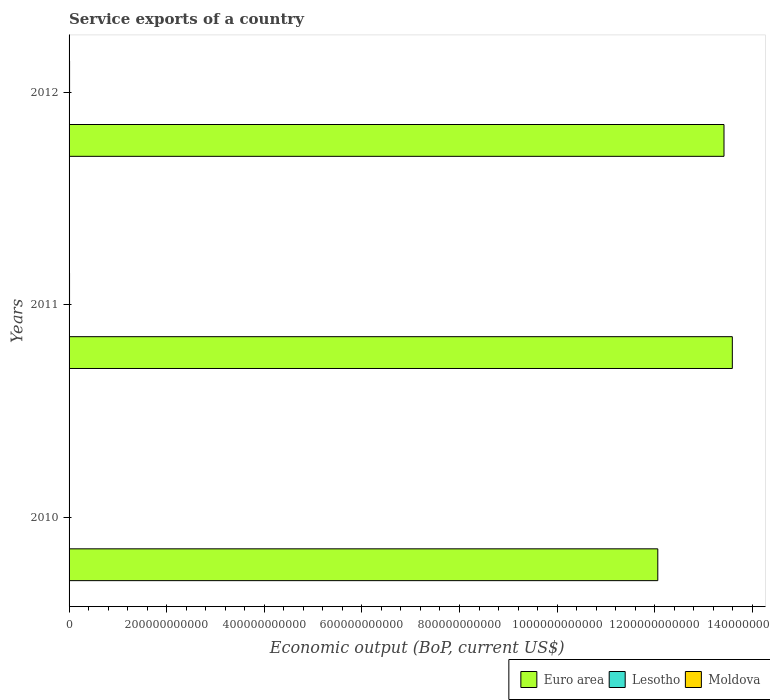How many different coloured bars are there?
Your answer should be compact. 3. How many groups of bars are there?
Keep it short and to the point. 3. Are the number of bars per tick equal to the number of legend labels?
Ensure brevity in your answer.  Yes. How many bars are there on the 3rd tick from the top?
Your answer should be very brief. 3. What is the label of the 2nd group of bars from the top?
Offer a terse response. 2011. In how many cases, is the number of bars for a given year not equal to the number of legend labels?
Keep it short and to the point. 0. What is the service exports in Moldova in 2011?
Make the answer very short. 9.60e+08. Across all years, what is the maximum service exports in Lesotho?
Your answer should be very brief. 7.29e+07. Across all years, what is the minimum service exports in Lesotho?
Your answer should be compact. 4.77e+07. In which year was the service exports in Euro area maximum?
Offer a terse response. 2011. In which year was the service exports in Moldova minimum?
Your answer should be very brief. 2010. What is the total service exports in Lesotho in the graph?
Your answer should be compact. 1.71e+08. What is the difference between the service exports in Lesotho in 2010 and that in 2011?
Ensure brevity in your answer.  -3.10e+06. What is the difference between the service exports in Lesotho in 2010 and the service exports in Euro area in 2012?
Give a very brief answer. -1.34e+12. What is the average service exports in Lesotho per year?
Offer a very short reply. 5.72e+07. In the year 2012, what is the difference between the service exports in Moldova and service exports in Euro area?
Provide a short and direct response. -1.34e+12. What is the ratio of the service exports in Lesotho in 2010 to that in 2012?
Provide a short and direct response. 0.65. Is the service exports in Euro area in 2010 less than that in 2011?
Provide a short and direct response. Yes. What is the difference between the highest and the second highest service exports in Euro area?
Your answer should be compact. 1.71e+1. What is the difference between the highest and the lowest service exports in Moldova?
Offer a very short reply. 2.51e+08. Is the sum of the service exports in Euro area in 2011 and 2012 greater than the maximum service exports in Lesotho across all years?
Provide a succinct answer. Yes. What does the 1st bar from the top in 2011 represents?
Keep it short and to the point. Moldova. What does the 1st bar from the bottom in 2012 represents?
Make the answer very short. Euro area. How many bars are there?
Make the answer very short. 9. How many years are there in the graph?
Provide a succinct answer. 3. What is the difference between two consecutive major ticks on the X-axis?
Provide a succinct answer. 2.00e+11. Where does the legend appear in the graph?
Make the answer very short. Bottom right. How are the legend labels stacked?
Your answer should be compact. Horizontal. What is the title of the graph?
Provide a short and direct response. Service exports of a country. Does "Costa Rica" appear as one of the legend labels in the graph?
Your response must be concise. No. What is the label or title of the X-axis?
Give a very brief answer. Economic output (BoP, current US$). What is the label or title of the Y-axis?
Offer a terse response. Years. What is the Economic output (BoP, current US$) of Euro area in 2010?
Your response must be concise. 1.21e+12. What is the Economic output (BoP, current US$) of Lesotho in 2010?
Offer a terse response. 4.77e+07. What is the Economic output (BoP, current US$) of Moldova in 2010?
Make the answer very short. 7.83e+08. What is the Economic output (BoP, current US$) in Euro area in 2011?
Give a very brief answer. 1.36e+12. What is the Economic output (BoP, current US$) of Lesotho in 2011?
Your answer should be very brief. 5.08e+07. What is the Economic output (BoP, current US$) in Moldova in 2011?
Offer a very short reply. 9.60e+08. What is the Economic output (BoP, current US$) in Euro area in 2012?
Your answer should be compact. 1.34e+12. What is the Economic output (BoP, current US$) in Lesotho in 2012?
Provide a succinct answer. 7.29e+07. What is the Economic output (BoP, current US$) of Moldova in 2012?
Your answer should be very brief. 1.03e+09. Across all years, what is the maximum Economic output (BoP, current US$) in Euro area?
Provide a short and direct response. 1.36e+12. Across all years, what is the maximum Economic output (BoP, current US$) in Lesotho?
Your answer should be compact. 7.29e+07. Across all years, what is the maximum Economic output (BoP, current US$) in Moldova?
Ensure brevity in your answer.  1.03e+09. Across all years, what is the minimum Economic output (BoP, current US$) in Euro area?
Your answer should be compact. 1.21e+12. Across all years, what is the minimum Economic output (BoP, current US$) in Lesotho?
Provide a short and direct response. 4.77e+07. Across all years, what is the minimum Economic output (BoP, current US$) in Moldova?
Offer a terse response. 7.83e+08. What is the total Economic output (BoP, current US$) of Euro area in the graph?
Keep it short and to the point. 3.91e+12. What is the total Economic output (BoP, current US$) in Lesotho in the graph?
Your response must be concise. 1.71e+08. What is the total Economic output (BoP, current US$) in Moldova in the graph?
Your response must be concise. 2.78e+09. What is the difference between the Economic output (BoP, current US$) of Euro area in 2010 and that in 2011?
Make the answer very short. -1.53e+11. What is the difference between the Economic output (BoP, current US$) of Lesotho in 2010 and that in 2011?
Your response must be concise. -3.10e+06. What is the difference between the Economic output (BoP, current US$) of Moldova in 2010 and that in 2011?
Your answer should be very brief. -1.77e+08. What is the difference between the Economic output (BoP, current US$) in Euro area in 2010 and that in 2012?
Offer a very short reply. -1.36e+11. What is the difference between the Economic output (BoP, current US$) in Lesotho in 2010 and that in 2012?
Your answer should be compact. -2.52e+07. What is the difference between the Economic output (BoP, current US$) of Moldova in 2010 and that in 2012?
Give a very brief answer. -2.51e+08. What is the difference between the Economic output (BoP, current US$) in Euro area in 2011 and that in 2012?
Provide a short and direct response. 1.71e+1. What is the difference between the Economic output (BoP, current US$) in Lesotho in 2011 and that in 2012?
Offer a very short reply. -2.21e+07. What is the difference between the Economic output (BoP, current US$) of Moldova in 2011 and that in 2012?
Keep it short and to the point. -7.41e+07. What is the difference between the Economic output (BoP, current US$) in Euro area in 2010 and the Economic output (BoP, current US$) in Lesotho in 2011?
Give a very brief answer. 1.21e+12. What is the difference between the Economic output (BoP, current US$) of Euro area in 2010 and the Economic output (BoP, current US$) of Moldova in 2011?
Offer a very short reply. 1.21e+12. What is the difference between the Economic output (BoP, current US$) in Lesotho in 2010 and the Economic output (BoP, current US$) in Moldova in 2011?
Offer a very short reply. -9.12e+08. What is the difference between the Economic output (BoP, current US$) in Euro area in 2010 and the Economic output (BoP, current US$) in Lesotho in 2012?
Your answer should be very brief. 1.21e+12. What is the difference between the Economic output (BoP, current US$) of Euro area in 2010 and the Economic output (BoP, current US$) of Moldova in 2012?
Your response must be concise. 1.21e+12. What is the difference between the Economic output (BoP, current US$) in Lesotho in 2010 and the Economic output (BoP, current US$) in Moldova in 2012?
Provide a succinct answer. -9.86e+08. What is the difference between the Economic output (BoP, current US$) of Euro area in 2011 and the Economic output (BoP, current US$) of Lesotho in 2012?
Ensure brevity in your answer.  1.36e+12. What is the difference between the Economic output (BoP, current US$) in Euro area in 2011 and the Economic output (BoP, current US$) in Moldova in 2012?
Your response must be concise. 1.36e+12. What is the difference between the Economic output (BoP, current US$) in Lesotho in 2011 and the Economic output (BoP, current US$) in Moldova in 2012?
Your answer should be very brief. -9.83e+08. What is the average Economic output (BoP, current US$) in Euro area per year?
Your answer should be compact. 1.30e+12. What is the average Economic output (BoP, current US$) in Lesotho per year?
Keep it short and to the point. 5.72e+07. What is the average Economic output (BoP, current US$) in Moldova per year?
Offer a very short reply. 9.26e+08. In the year 2010, what is the difference between the Economic output (BoP, current US$) of Euro area and Economic output (BoP, current US$) of Lesotho?
Make the answer very short. 1.21e+12. In the year 2010, what is the difference between the Economic output (BoP, current US$) of Euro area and Economic output (BoP, current US$) of Moldova?
Give a very brief answer. 1.21e+12. In the year 2010, what is the difference between the Economic output (BoP, current US$) of Lesotho and Economic output (BoP, current US$) of Moldova?
Offer a very short reply. -7.35e+08. In the year 2011, what is the difference between the Economic output (BoP, current US$) in Euro area and Economic output (BoP, current US$) in Lesotho?
Your response must be concise. 1.36e+12. In the year 2011, what is the difference between the Economic output (BoP, current US$) of Euro area and Economic output (BoP, current US$) of Moldova?
Your answer should be very brief. 1.36e+12. In the year 2011, what is the difference between the Economic output (BoP, current US$) in Lesotho and Economic output (BoP, current US$) in Moldova?
Offer a very short reply. -9.09e+08. In the year 2012, what is the difference between the Economic output (BoP, current US$) of Euro area and Economic output (BoP, current US$) of Lesotho?
Your response must be concise. 1.34e+12. In the year 2012, what is the difference between the Economic output (BoP, current US$) of Euro area and Economic output (BoP, current US$) of Moldova?
Make the answer very short. 1.34e+12. In the year 2012, what is the difference between the Economic output (BoP, current US$) in Lesotho and Economic output (BoP, current US$) in Moldova?
Offer a terse response. -9.61e+08. What is the ratio of the Economic output (BoP, current US$) in Euro area in 2010 to that in 2011?
Offer a very short reply. 0.89. What is the ratio of the Economic output (BoP, current US$) of Lesotho in 2010 to that in 2011?
Your answer should be very brief. 0.94. What is the ratio of the Economic output (BoP, current US$) in Moldova in 2010 to that in 2011?
Your answer should be very brief. 0.82. What is the ratio of the Economic output (BoP, current US$) of Euro area in 2010 to that in 2012?
Provide a short and direct response. 0.9. What is the ratio of the Economic output (BoP, current US$) in Lesotho in 2010 to that in 2012?
Ensure brevity in your answer.  0.65. What is the ratio of the Economic output (BoP, current US$) in Moldova in 2010 to that in 2012?
Offer a very short reply. 0.76. What is the ratio of the Economic output (BoP, current US$) in Euro area in 2011 to that in 2012?
Give a very brief answer. 1.01. What is the ratio of the Economic output (BoP, current US$) in Lesotho in 2011 to that in 2012?
Keep it short and to the point. 0.7. What is the ratio of the Economic output (BoP, current US$) of Moldova in 2011 to that in 2012?
Your answer should be compact. 0.93. What is the difference between the highest and the second highest Economic output (BoP, current US$) in Euro area?
Your answer should be compact. 1.71e+1. What is the difference between the highest and the second highest Economic output (BoP, current US$) of Lesotho?
Provide a short and direct response. 2.21e+07. What is the difference between the highest and the second highest Economic output (BoP, current US$) in Moldova?
Offer a terse response. 7.41e+07. What is the difference between the highest and the lowest Economic output (BoP, current US$) of Euro area?
Offer a terse response. 1.53e+11. What is the difference between the highest and the lowest Economic output (BoP, current US$) in Lesotho?
Offer a very short reply. 2.52e+07. What is the difference between the highest and the lowest Economic output (BoP, current US$) of Moldova?
Make the answer very short. 2.51e+08. 